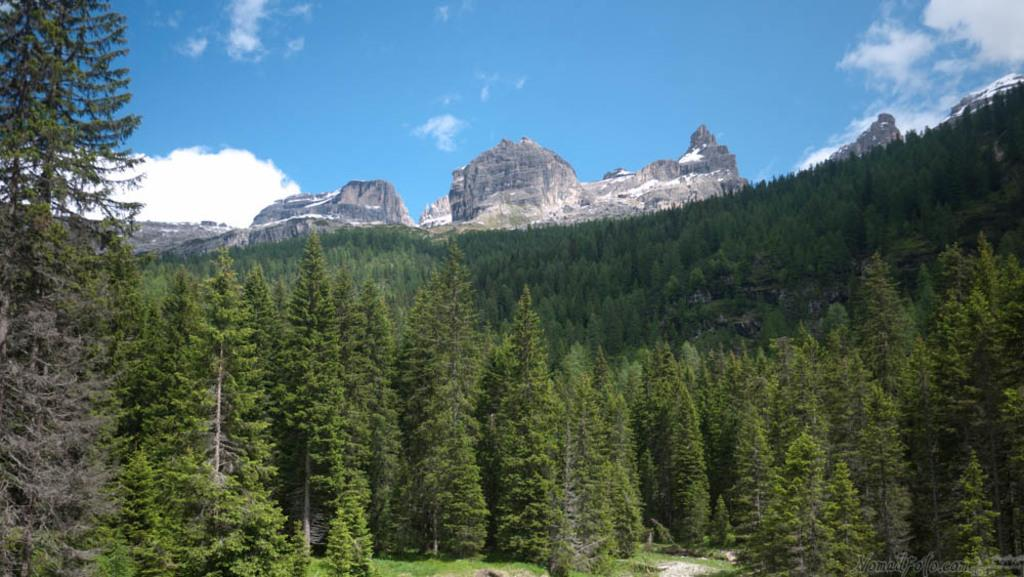What type of vegetation can be seen in the image? There are trees in the image. What can be seen in the distance in the image? There are hills and rocks in the background of the image. What is visible at the top of the image? The sky is visible at the top of the image. What is the color of the sky in the image? The sky is blue in color. Can you tell me how many times the children jump during recess in the image? There are no children or recess present in the image; it features trees, hills, rocks, and a blue sky. What is the limit of the rocks in the image? There is no limit mentioned for the rocks in the image; they are simply visible in the background. 